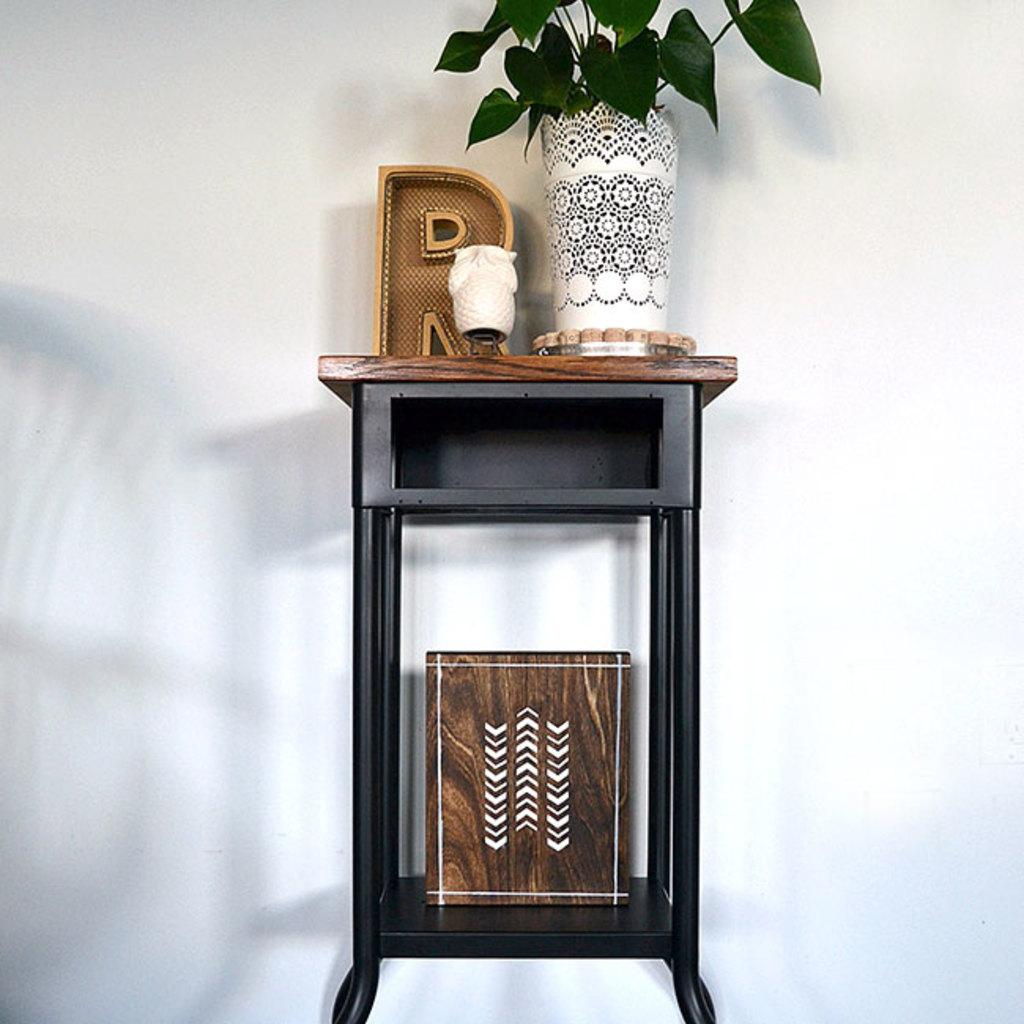What type of furniture is present in the image? There is a table in the image. What is the background of the table in the image? The table is near a white wall. What can be seen in the white pot in the image? There are leaves in the white pot in the image. What is placed on the table in the image? There are objects on the table. Is there a swing visible in the image? No, there is no swing present in the image. Can you see anyone driving in the image? No, there is no driving activity depicted in the image. 